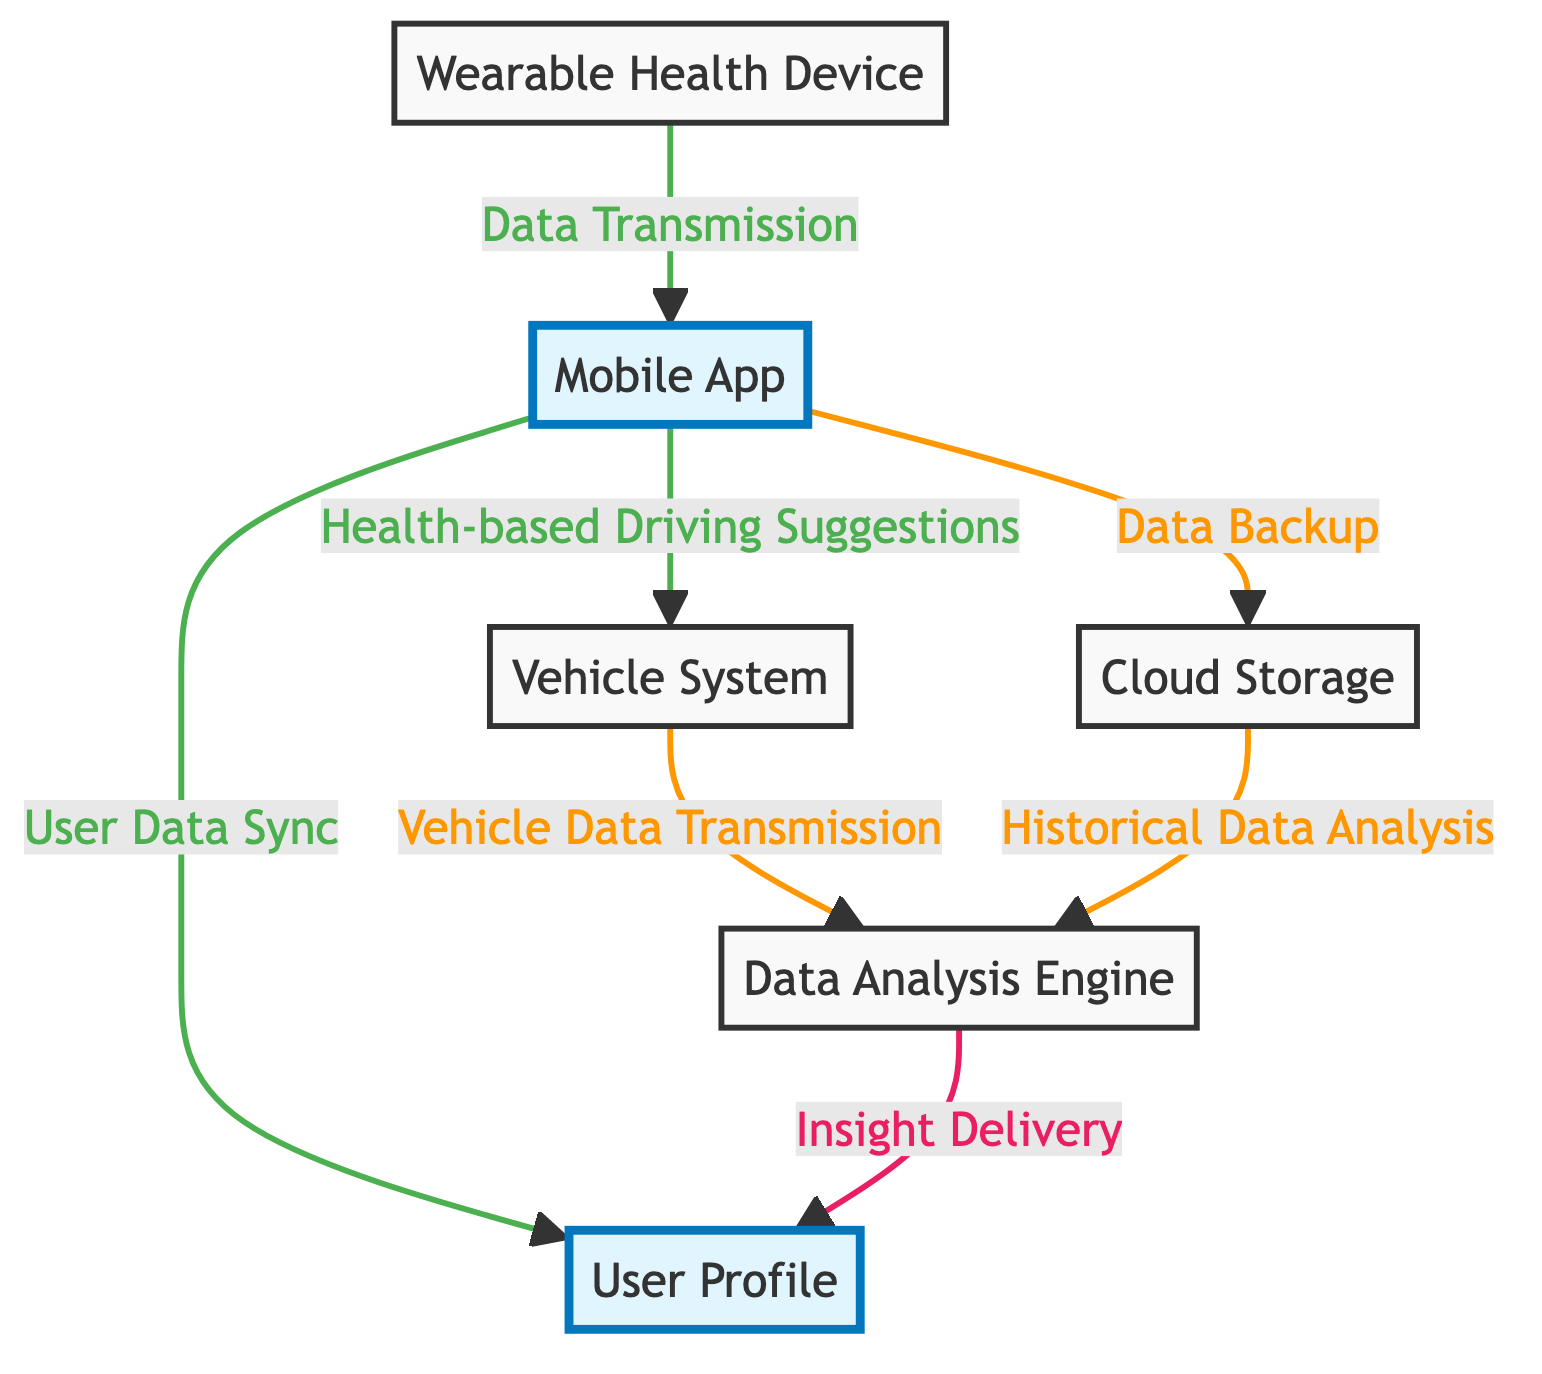What is the first step in the data integration process? The first step is the data transmission from the Wearable Health Device to the Mobile App. This can be observed as the initial arrow pointing from the wearable device to the mobile app in the diagram.
Answer: Data Transmission How many main components are there in the diagram? The main components are User Profile, Wearable Health Device, Mobile App, Vehicle System, Cloud Storage, and Data Analysis Engine. Counting these nodes results in a total of six components.
Answer: Six What role does the Cloud Storage play in the system? The Cloud Storage is responsible for data backup and facilitates historical data analysis through its connection to the Data Analysis Engine, as illustrated by the arrows indicating these functions in the diagram.
Answer: Data Backup, Historical Data Analysis Which component provides driving suggestions based on health data? The Mobile App is indicated to provide Health-based Driving Suggestions to the Vehicle System, as shown by the arrow connecting these two nodes in the diagram.
Answer: Mobile App How does the Data Analysis Engine receive information? The Data Analysis Engine receives information through Vehicle Data Transmission from the Vehicle System and Historical Data Analysis from Cloud Storage. The diagram shows arrows pointing from these two components to the Data Analysis Engine, indicating the flow of data into it.
Answer: Vehicle System, Cloud Storage Which component has a direct connection to the User Profile for syncing data? The Mobile App has a direct connection to the User Profile as represented by the arrow labeled User Data Sync in the diagram, indicating that user data is synchronized through this relationship.
Answer: Mobile App What is the outcome of the Data Analysis Engine? The outcome is Insight Delivery to the User Profile, represented by the arrow directed from the Data Analysis Engine to the User Profile, showing that the engine processes data and provides insights.
Answer: Insight Delivery What color highlights the User Profile in the diagram? The User Profile is highlighted in a distinct blue color, as indicated by the class definitions in the code specifying the highlight styling for this node.
Answer: Blue How many data flows are indicated from the Mobile App to other components? There are three data flows: to the User Profile, Vehicle System, and Cloud Storage. By counting the arrows extending from the Mobile App, we see that it connects to these three components.
Answer: Three 